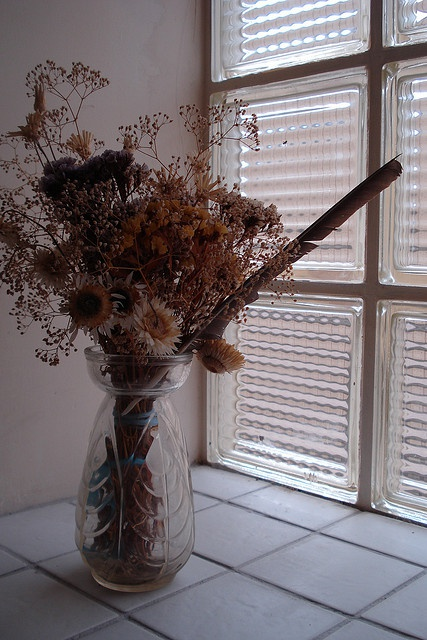Describe the objects in this image and their specific colors. I can see potted plant in gray, black, maroon, and darkgray tones and vase in gray and black tones in this image. 